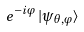<formula> <loc_0><loc_0><loc_500><loc_500>e ^ { - i \varphi } \, | \psi _ { \theta , \varphi } \rangle</formula> 